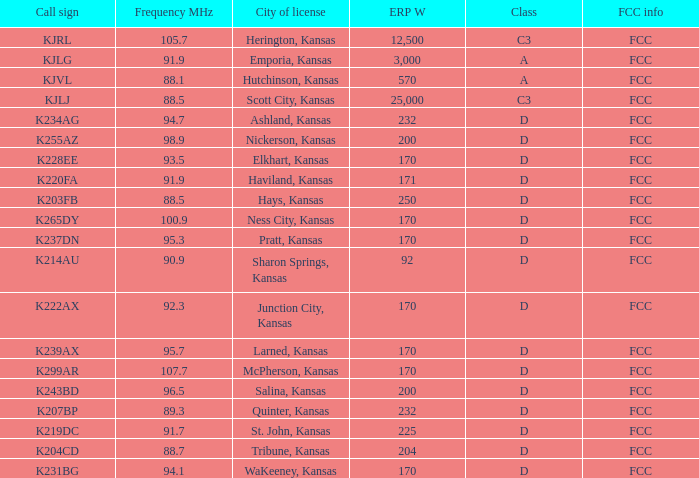7 mhz? 204.0. 